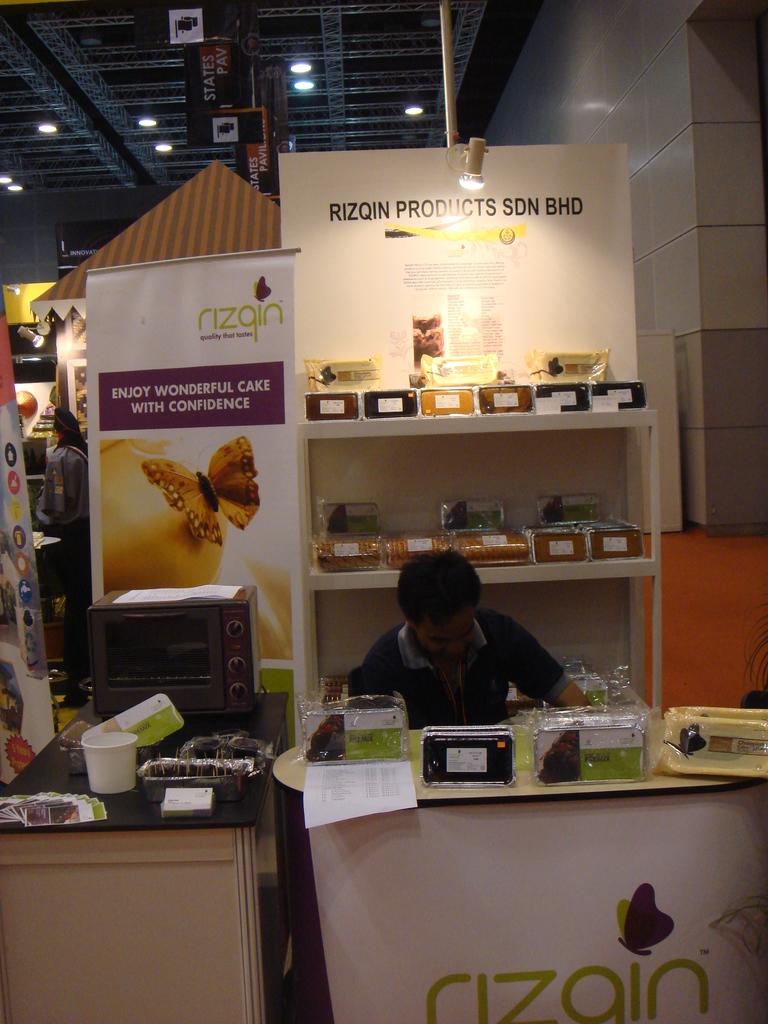What brand is displayed here?
Provide a short and direct response. Rizgin. What is the slogan?
Offer a terse response. Enjoy wonderful cake with confidence. 